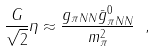Convert formula to latex. <formula><loc_0><loc_0><loc_500><loc_500>\frac { G } { \sqrt { 2 } } \eta \approx \frac { g _ { \pi N N } \bar { g } ^ { 0 } _ { \pi N N } } { m _ { \pi } ^ { 2 } } \ ,</formula> 